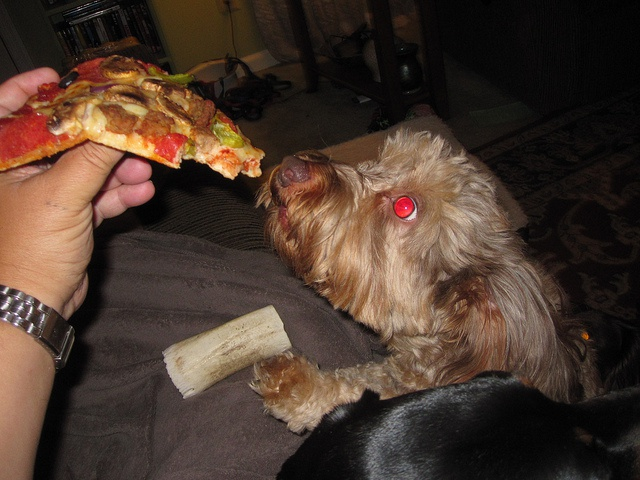Describe the objects in this image and their specific colors. I can see dog in black, gray, maroon, and tan tones, people in black, gray, and tan tones, and pizza in black, brown, maroon, and tan tones in this image. 